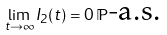<formula> <loc_0><loc_0><loc_500><loc_500>\lim _ { t \to \infty } I _ { 2 } ( t ) = 0 \, \mathbb { P } \text {-a.s.}</formula> 